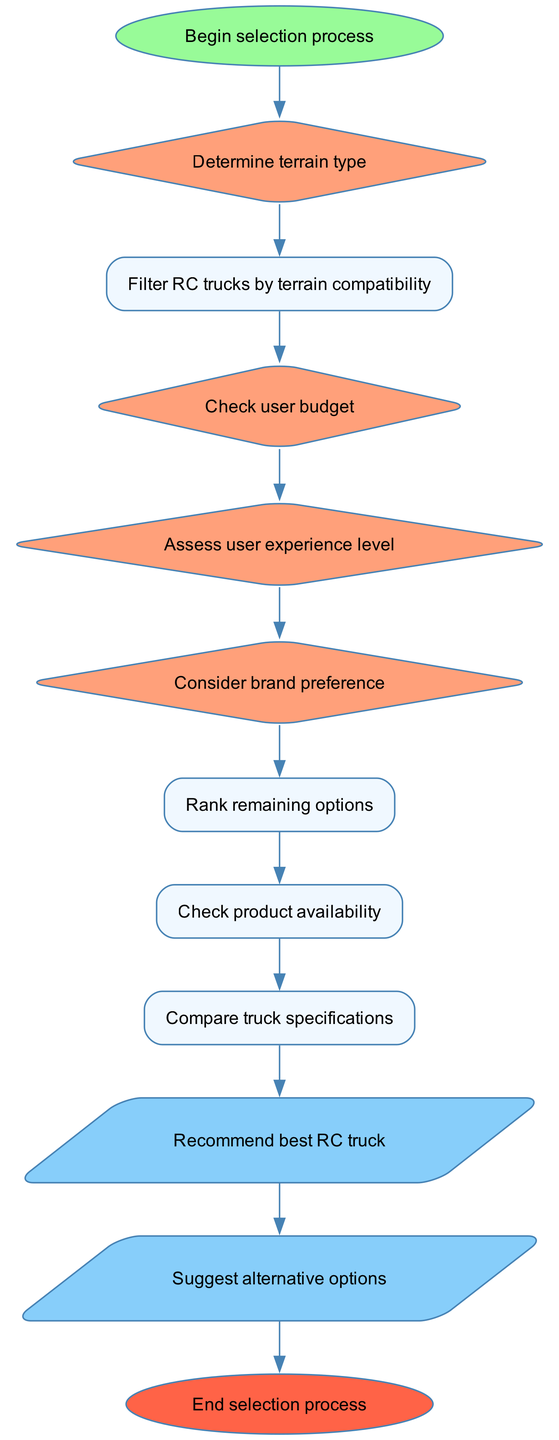What is the first step in the selection process? The first step is represented by the 'start' node, which transitions into the decision node labeled 'Determine terrain type.' This indicates that the process starts by determining the type of terrain the user will be dealing with.
Answer: Begin selection process How many decision nodes are in the diagram? The diagram contains four decision nodes: 'Determine terrain type,' 'Check user budget,' 'Assess user experience level,' and 'Consider brand preference.' Thus, the total is four.
Answer: 4 What is the last process before the recommendations are made? The last process node before recommendations is 'Compare truck specifications,' which is the final step before producing the output of the best RC truck recommendation.
Answer: Compare truck specifications What follows after the 'Check product availability' process? After the 'Check product availability' process, the flow moves to the 'Compare truck specifications' process, where the specifications of the trucks are compared before making the recommendation.
Answer: Compare truck specifications What outputs are produced after the recommendation is made? The outputs produced are 'Recommend best RC truck' and 'Suggest alternative options.' These represent the final actions based on the previous processes and decisions.
Answer: Recommend best RC truck, Suggest alternative options Which node assesses user experience? The node that assesses user experience is labeled 'Assess user experience level,' and it comes after the budget check in the flow to ensure the truck suits the user’s proficiency.
Answer: Assess user experience level What is the shape of the end node? The end node has an oval shape as indicated in the flowchart. The design choice of using an oval signifies the conclusion of the flowchart’s process.
Answer: oval What is the relationship between 'rankOptions' and 'compareSpecs'? The relationship is that 'rankOptions' is connected directly to 'compareSpecs.' This indicates that after ranking the remaining options, the next step is to compare their specifications before making a recommendation.
Answer: rankOptions → compareSpecs 